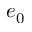<formula> <loc_0><loc_0><loc_500><loc_500>e _ { 0 }</formula> 